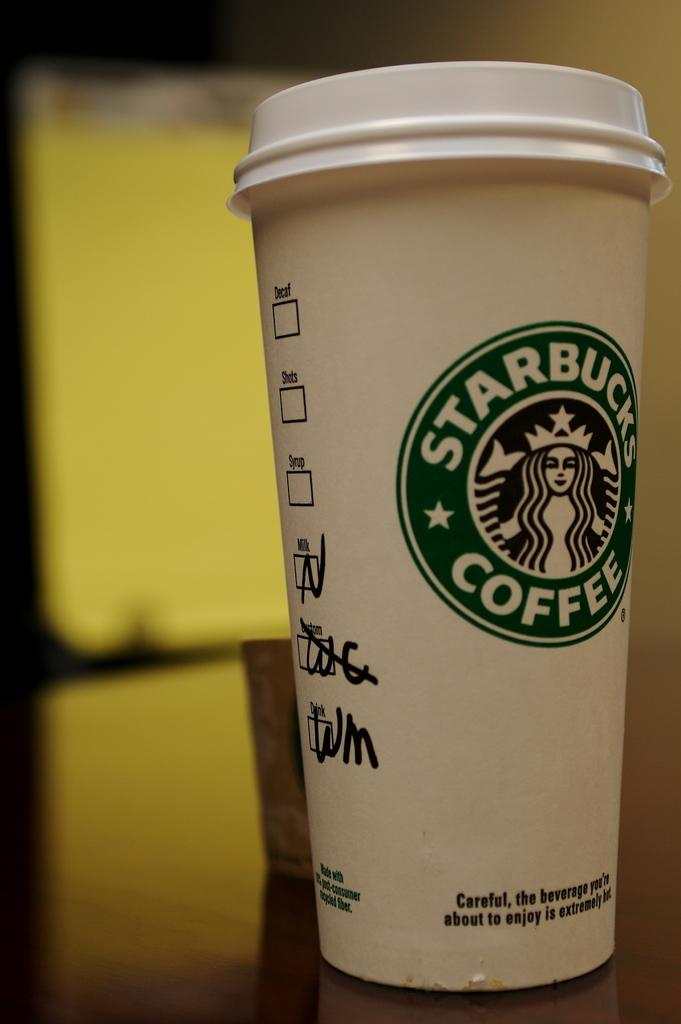What is present on the table in the image? There are objects on the table in the image. What can be seen on the wooden surface in the image? There is a reflection on the wooden surface in the image. Where is the object located on the left side of the image? There is an object at the left side of the image. How many rings are visible on the object at the left side of the image? There are no rings visible on the object at the left side of the image. What type of bushes can be seen growing near the table in the image? There are no bushes present in the image. 